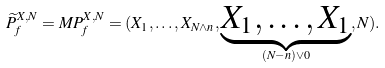<formula> <loc_0><loc_0><loc_500><loc_500>\widetilde { P } _ { f } ^ { X , N } = M P _ { f } ^ { X , N } = ( X _ { 1 } , \dots , X _ { N \wedge n } , \underbrace { X _ { 1 } , \dots , X _ { 1 } } _ { ( N - n ) \vee 0 } , N ) .</formula> 